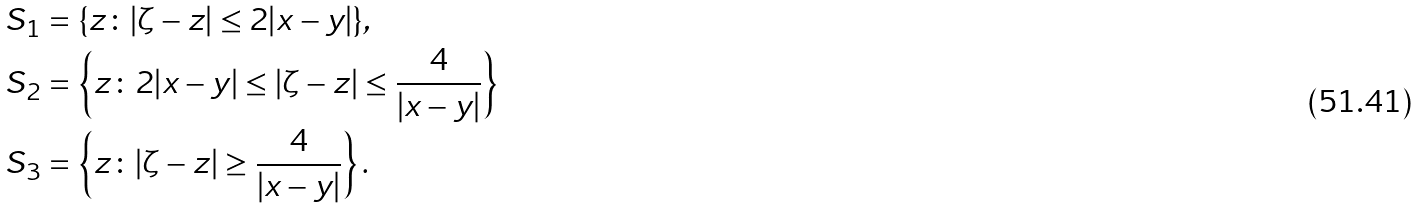<formula> <loc_0><loc_0><loc_500><loc_500>& S _ { 1 } = \{ z \colon | \zeta - z | \leq 2 | x - y | \} , \\ & S _ { 2 } = \left \{ z \colon 2 | x - y | \leq | \zeta - z | \leq \frac { 4 } { | x - y | } \right \} \\ & S _ { 3 } = \left \{ z \colon | \zeta - z | \geq \frac { 4 } { | x - y | } \right \} .</formula> 